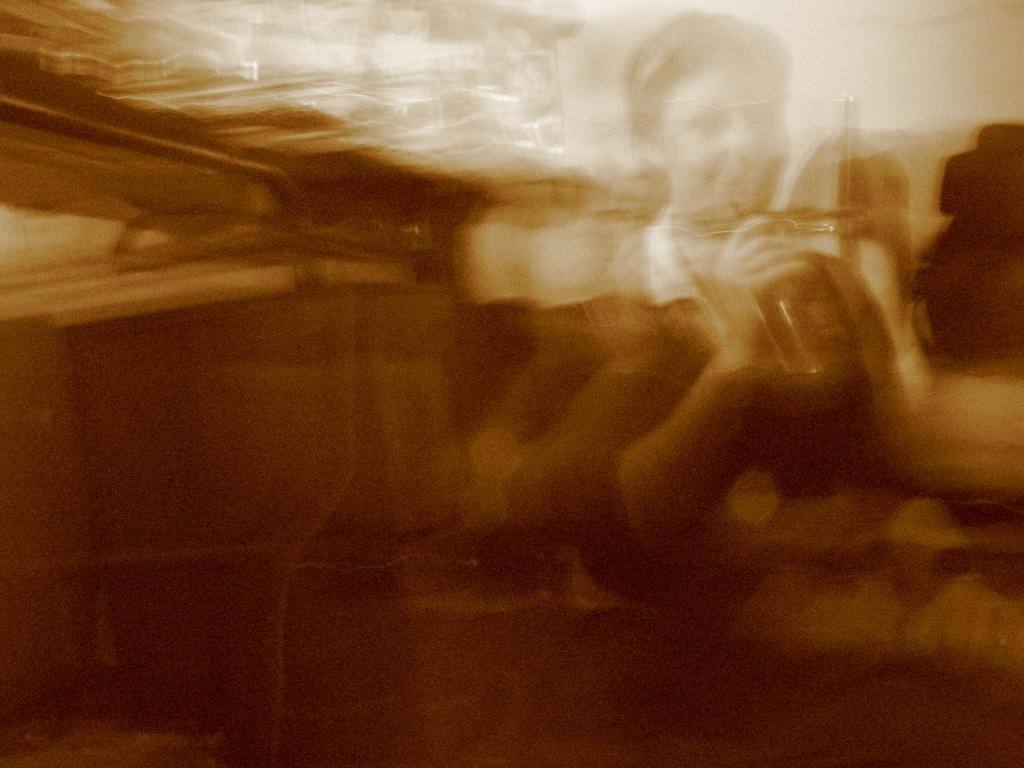Can you confirm if there is a person in the image? The image quality is low, so it is difficult to definitively confirm the presence of a person. If there is a person in the image, what might they be holding? If there is a person in the image and they are holding an object, it is not possible to determine the nature of the object based on the provided facts. Can you tell me how many baseballs the stranger is holding in the image? There is no stranger or baseballs present in the image. What type of wheel is visible in the image? There is no wheel present in the image. 